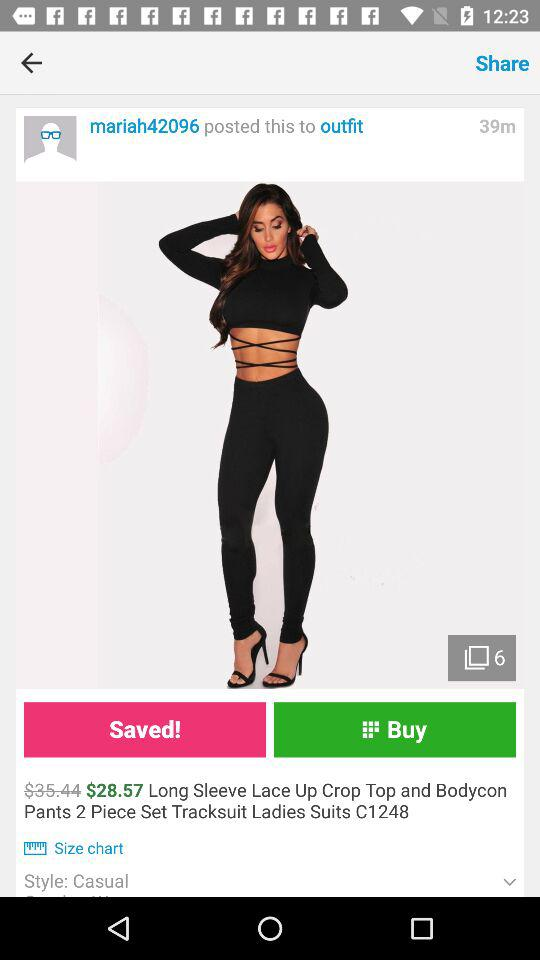What is the currency of price? The currency of price is the dollar. 